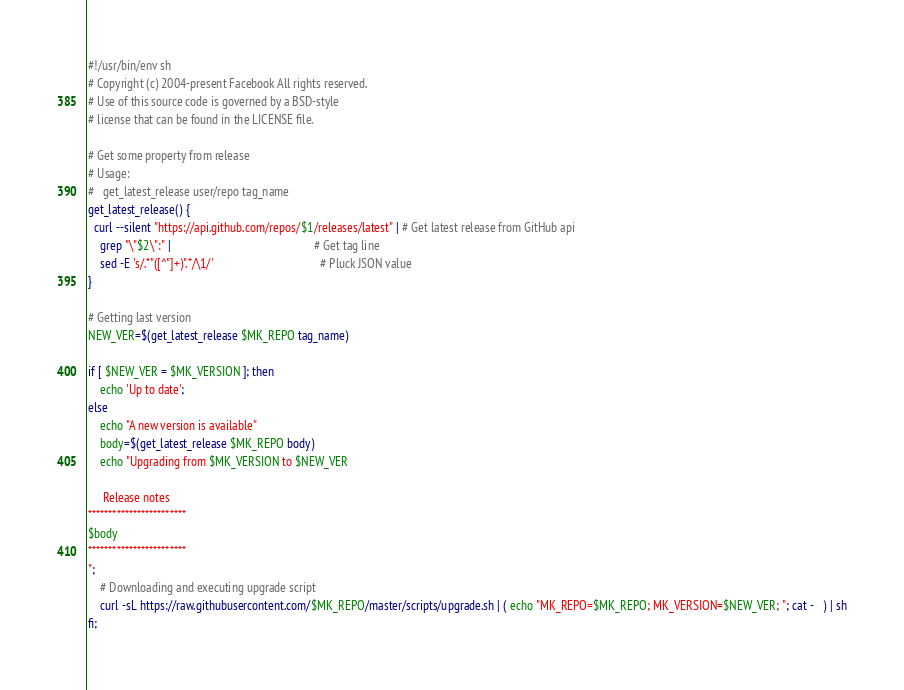<code> <loc_0><loc_0><loc_500><loc_500><_Bash_>#!/usr/bin/env sh
# Copyright (c) 2004-present Facebook All rights reserved.
# Use of this source code is governed by a BSD-style
# license that can be found in the LICENSE file.

# Get some property from release
# Usage:
#   get_latest_release user/repo tag_name
get_latest_release() {
  curl --silent "https://api.github.com/repos/$1/releases/latest" | # Get latest release from GitHub api
    grep "\"$2\":" |                                                # Get tag line
    sed -E 's/.*"([^"]+)".*/\1/'                                    # Pluck JSON value
}

# Getting last version
NEW_VER=$(get_latest_release $MK_REPO tag_name)

if [ $NEW_VER = $MK_VERSION ]; then
    echo 'Up to date';
else
    echo "A new version is available"
    body=$(get_latest_release $MK_REPO body)
    echo "Upgrading from $MK_VERSION to $NEW_VER

     Release notes
************************
$body
************************
";
    # Downloading and executing upgrade script
    curl -sL https://raw.githubusercontent.com/$MK_REPO/master/scripts/upgrade.sh | ( echo "MK_REPO=$MK_REPO; MK_VERSION=$NEW_VER; "; cat -   ) | sh
fi;</code> 